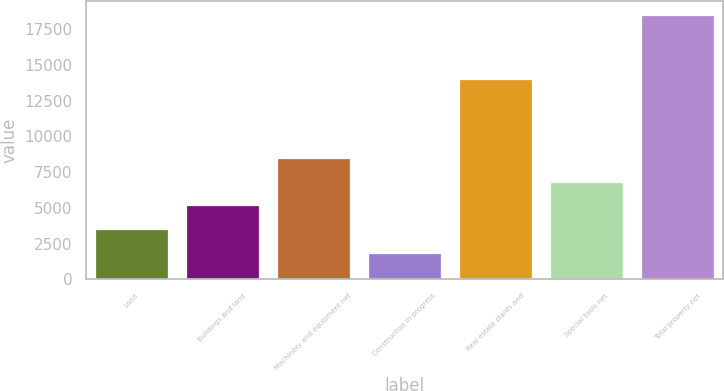Convert chart. <chart><loc_0><loc_0><loc_500><loc_500><bar_chart><fcel>Land<fcel>Buildings and land<fcel>Machinery and equipment net<fcel>Construction in progress<fcel>Real estate plants and<fcel>Special tools net<fcel>Total property net<nl><fcel>3504.2<fcel>5170.4<fcel>8502.8<fcel>1838<fcel>14008<fcel>6836.6<fcel>18500<nl></chart> 